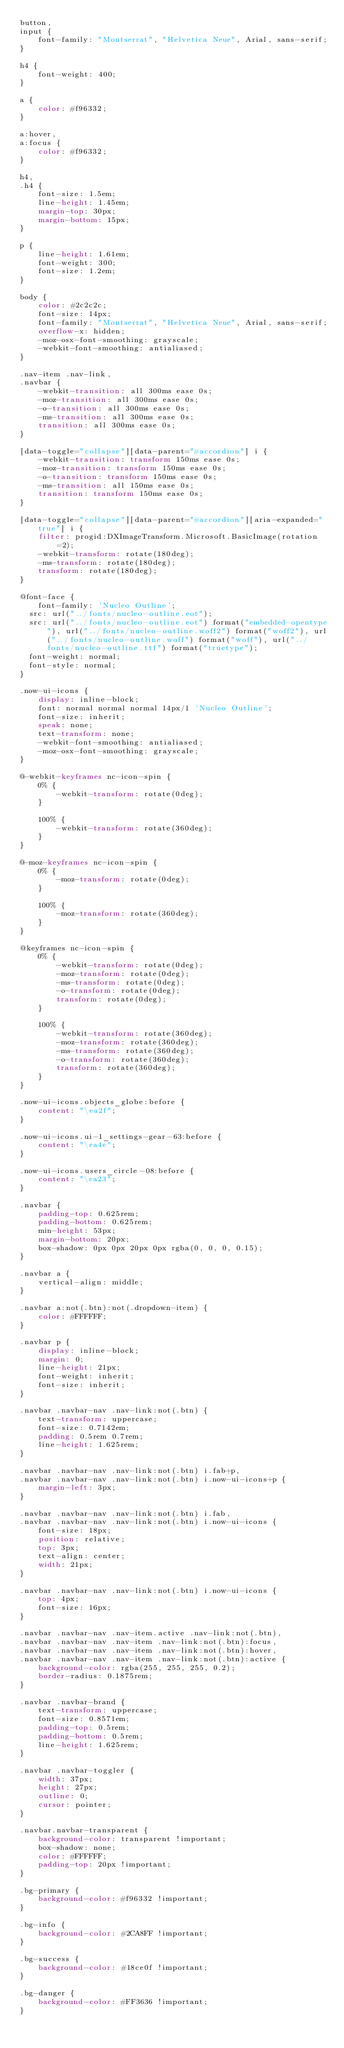Convert code to text. <code><loc_0><loc_0><loc_500><loc_500><_CSS_>button,
input {
    font-family: "Montserrat", "Helvetica Neue", Arial, sans-serif;
}

h4 {
    font-weight: 400;
}

a {
    color: #f96332;
}

a:hover,
a:focus {
    color: #f96332;
}

h4,
.h4 {
    font-size: 1.5em;
    line-height: 1.45em;
    margin-top: 30px;
    margin-bottom: 15px;
}

p {
    line-height: 1.61em;
    font-weight: 300;
    font-size: 1.2em;
}

body {
    color: #2c2c2c;
    font-size: 14px;
    font-family: "Montserrat", "Helvetica Neue", Arial, sans-serif;
    overflow-x: hidden;
    -moz-osx-font-smoothing: grayscale;
    -webkit-font-smoothing: antialiased;
}

.nav-item .nav-link,
.navbar {
    -webkit-transition: all 300ms ease 0s;
    -moz-transition: all 300ms ease 0s;
    -o-transition: all 300ms ease 0s;
    -ms-transition: all 300ms ease 0s;
    transition: all 300ms ease 0s;
}

[data-toggle="collapse"][data-parent="#accordion"] i {
    -webkit-transition: transform 150ms ease 0s;
    -moz-transition: transform 150ms ease 0s;
    -o-transition: transform 150ms ease 0s;
    -ms-transition: all 150ms ease 0s;
    transition: transform 150ms ease 0s;
}

[data-toggle="collapse"][data-parent="#accordion"][aria-expanded="true"] i {
    filter: progid:DXImageTransform.Microsoft.BasicImage(rotation=2);
    -webkit-transform: rotate(180deg);
    -ms-transform: rotate(180deg);
    transform: rotate(180deg);
}

@font-face {
    font-family: 'Nucleo Outline';
  src: url("../fonts/nucleo-outline.eot");
  src: url("../fonts/nucleo-outline.eot") format("embedded-opentype"), url("../fonts/nucleo-outline.woff2") format("woff2"), url("../fonts/nucleo-outline.woff") format("woff"), url("../fonts/nucleo-outline.ttf") format("truetype");
  font-weight: normal;
  font-style: normal;
}

.now-ui-icons {
    display: inline-block;
    font: normal normal normal 14px/1 'Nucleo Outline';
    font-size: inherit;
    speak: none;
    text-transform: none;
    -webkit-font-smoothing: antialiased;
    -moz-osx-font-smoothing: grayscale;
}

@-webkit-keyframes nc-icon-spin {
    0% {
        -webkit-transform: rotate(0deg);
    }

    100% {
        -webkit-transform: rotate(360deg);
    }
}

@-moz-keyframes nc-icon-spin {
    0% {
        -moz-transform: rotate(0deg);
    }

    100% {
        -moz-transform: rotate(360deg);
    }
}

@keyframes nc-icon-spin {
    0% {
        -webkit-transform: rotate(0deg);
        -moz-transform: rotate(0deg);
        -ms-transform: rotate(0deg);
        -o-transform: rotate(0deg);
        transform: rotate(0deg);
    }

    100% {
        -webkit-transform: rotate(360deg);
        -moz-transform: rotate(360deg);
        -ms-transform: rotate(360deg);
        -o-transform: rotate(360deg);
        transform: rotate(360deg);
    }
}

.now-ui-icons.objects_globe:before {
    content: "\ea2f";
}

.now-ui-icons.ui-1_settings-gear-63:before {
    content: "\ea4e";
}

.now-ui-icons.users_circle-08:before {
    content: "\ea23";
}

.navbar {
    padding-top: 0.625rem;
    padding-bottom: 0.625rem;
    min-height: 53px;
    margin-bottom: 20px;
    box-shadow: 0px 0px 20px 0px rgba(0, 0, 0, 0.15);
}

.navbar a {
    vertical-align: middle;
}

.navbar a:not(.btn):not(.dropdown-item) {
    color: #FFFFFF;
}

.navbar p {
    display: inline-block;
    margin: 0;
    line-height: 21px;
    font-weight: inherit;
    font-size: inherit;
}

.navbar .navbar-nav .nav-link:not(.btn) {
    text-transform: uppercase;
    font-size: 0.7142em;
    padding: 0.5rem 0.7rem;
    line-height: 1.625rem;
}

.navbar .navbar-nav .nav-link:not(.btn) i.fab+p,
.navbar .navbar-nav .nav-link:not(.btn) i.now-ui-icons+p {
    margin-left: 3px;
}

.navbar .navbar-nav .nav-link:not(.btn) i.fab,
.navbar .navbar-nav .nav-link:not(.btn) i.now-ui-icons {
    font-size: 18px;
    position: relative;
    top: 3px;
    text-align: center;
    width: 21px;
}

.navbar .navbar-nav .nav-link:not(.btn) i.now-ui-icons {
    top: 4px;
    font-size: 16px;
}

.navbar .navbar-nav .nav-item.active .nav-link:not(.btn),
.navbar .navbar-nav .nav-item .nav-link:not(.btn):focus,
.navbar .navbar-nav .nav-item .nav-link:not(.btn):hover,
.navbar .navbar-nav .nav-item .nav-link:not(.btn):active {
    background-color: rgba(255, 255, 255, 0.2);
    border-radius: 0.1875rem;
}

.navbar .navbar-brand {
    text-transform: uppercase;
    font-size: 0.8571em;
    padding-top: 0.5rem;
    padding-bottom: 0.5rem;
    line-height: 1.625rem;
}

.navbar .navbar-toggler {
    width: 37px;
    height: 27px;
    outline: 0;
    cursor: pointer;
}

.navbar.navbar-transparent {
    background-color: transparent !important;
    box-shadow: none;
    color: #FFFFFF;
    padding-top: 20px !important;
}

.bg-primary {
    background-color: #f96332 !important;
}

.bg-info {
    background-color: #2CA8FF !important;
}

.bg-success {
    background-color: #18ce0f !important;
}

.bg-danger {
    background-color: #FF3636 !important;
}
</code> 